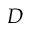Convert formula to latex. <formula><loc_0><loc_0><loc_500><loc_500>D</formula> 